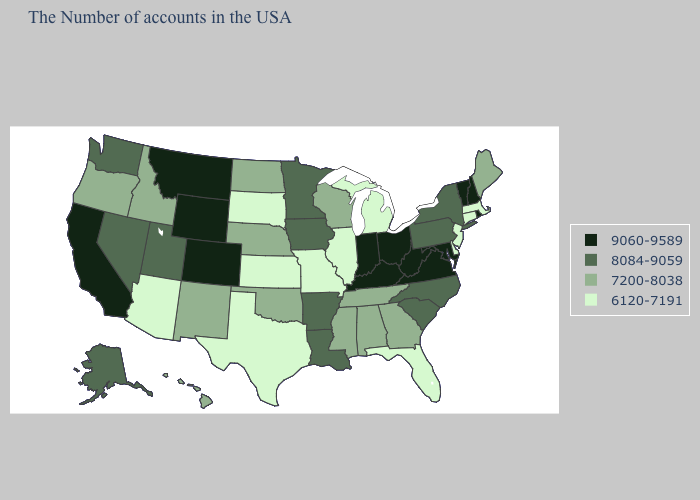What is the value of Iowa?
Answer briefly. 8084-9059. What is the highest value in states that border Vermont?
Quick response, please. 9060-9589. Is the legend a continuous bar?
Answer briefly. No. Name the states that have a value in the range 6120-7191?
Be succinct. Massachusetts, Connecticut, New Jersey, Delaware, Florida, Michigan, Illinois, Missouri, Kansas, Texas, South Dakota, Arizona. Among the states that border Ohio , does Michigan have the highest value?
Write a very short answer. No. Does the first symbol in the legend represent the smallest category?
Keep it brief. No. What is the value of New Mexico?
Keep it brief. 7200-8038. Name the states that have a value in the range 6120-7191?
Give a very brief answer. Massachusetts, Connecticut, New Jersey, Delaware, Florida, Michigan, Illinois, Missouri, Kansas, Texas, South Dakota, Arizona. Does Georgia have a lower value than Wisconsin?
Answer briefly. No. Name the states that have a value in the range 7200-8038?
Concise answer only. Maine, Georgia, Alabama, Tennessee, Wisconsin, Mississippi, Nebraska, Oklahoma, North Dakota, New Mexico, Idaho, Oregon, Hawaii. Name the states that have a value in the range 8084-9059?
Keep it brief. New York, Pennsylvania, North Carolina, South Carolina, Louisiana, Arkansas, Minnesota, Iowa, Utah, Nevada, Washington, Alaska. What is the value of North Carolina?
Quick response, please. 8084-9059. What is the value of Alaska?
Give a very brief answer. 8084-9059. Name the states that have a value in the range 8084-9059?
Quick response, please. New York, Pennsylvania, North Carolina, South Carolina, Louisiana, Arkansas, Minnesota, Iowa, Utah, Nevada, Washington, Alaska. What is the value of Utah?
Short answer required. 8084-9059. 